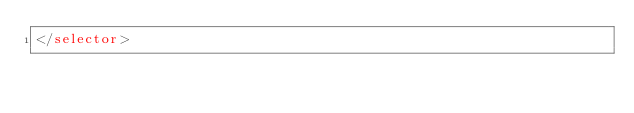Convert code to text. <code><loc_0><loc_0><loc_500><loc_500><_XML_></selector></code> 